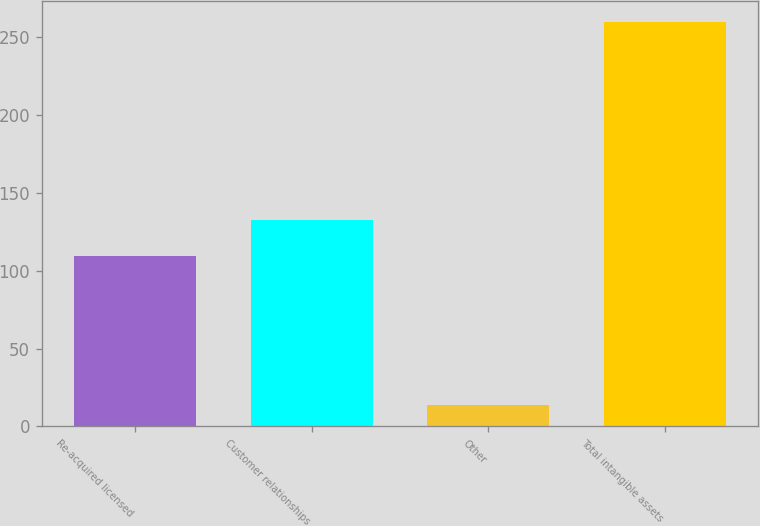<chart> <loc_0><loc_0><loc_500><loc_500><bar_chart><fcel>Re-acquired licensed<fcel>Customer relationships<fcel>Other<fcel>Total intangible assets<nl><fcel>109.1<fcel>132.14<fcel>13.5<fcel>259.64<nl></chart> 